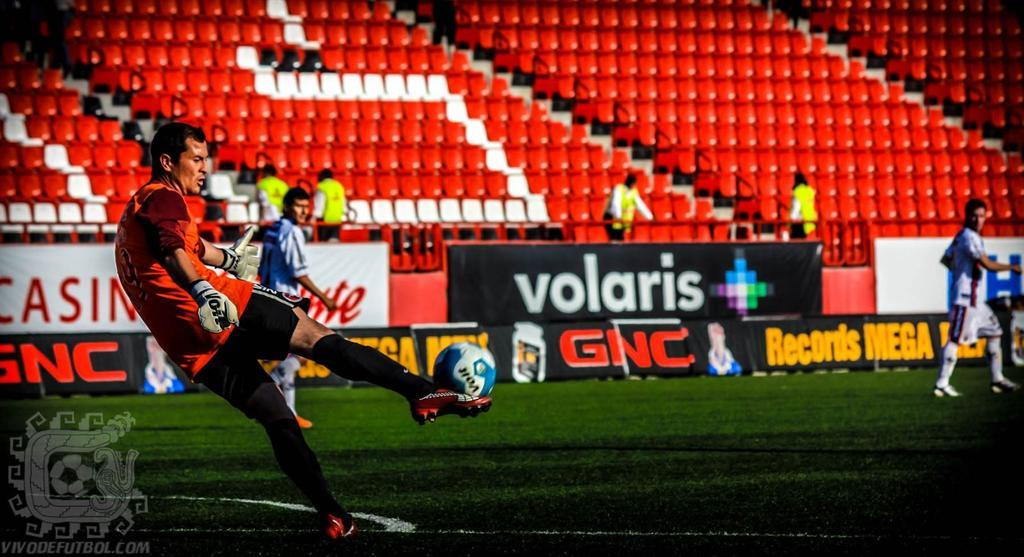<image>
Share a concise interpretation of the image provided. A soccer game that is sponsored by GNC. 